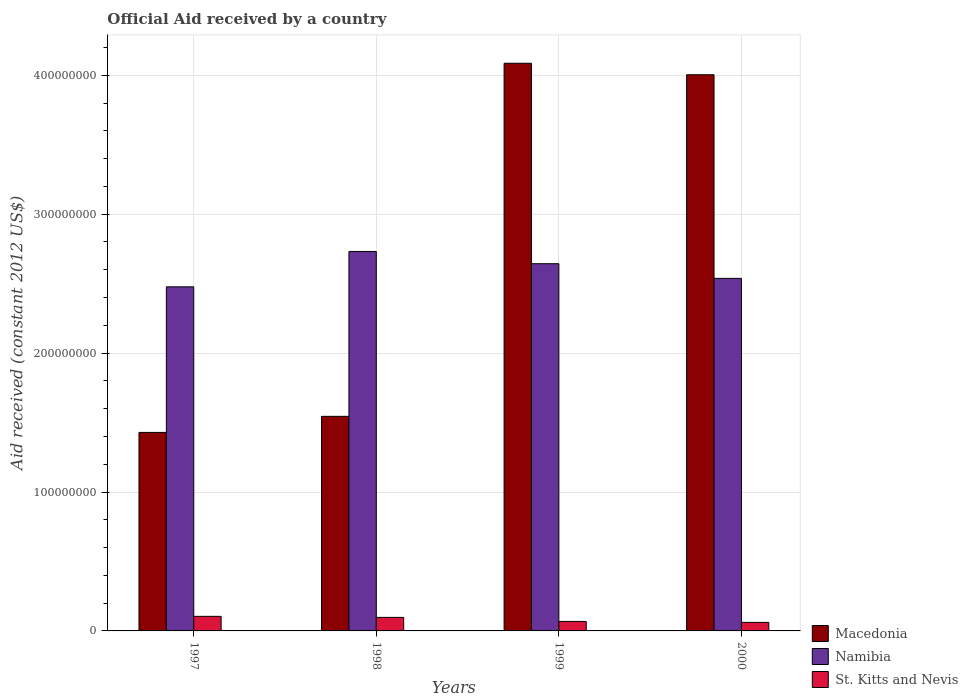How many different coloured bars are there?
Provide a succinct answer. 3. Are the number of bars per tick equal to the number of legend labels?
Your response must be concise. Yes. How many bars are there on the 1st tick from the left?
Provide a short and direct response. 3. How many bars are there on the 4th tick from the right?
Your answer should be compact. 3. What is the net official aid received in Macedonia in 1999?
Ensure brevity in your answer.  4.09e+08. Across all years, what is the maximum net official aid received in Namibia?
Give a very brief answer. 2.73e+08. Across all years, what is the minimum net official aid received in Namibia?
Offer a terse response. 2.48e+08. What is the total net official aid received in Namibia in the graph?
Offer a very short reply. 1.04e+09. What is the difference between the net official aid received in St. Kitts and Nevis in 1998 and that in 1999?
Keep it short and to the point. 2.92e+06. What is the difference between the net official aid received in Namibia in 1997 and the net official aid received in Macedonia in 1999?
Your response must be concise. -1.61e+08. What is the average net official aid received in St. Kitts and Nevis per year?
Your answer should be very brief. 8.30e+06. In the year 1999, what is the difference between the net official aid received in St. Kitts and Nevis and net official aid received in Macedonia?
Offer a very short reply. -4.02e+08. What is the ratio of the net official aid received in Namibia in 1997 to that in 1999?
Your answer should be compact. 0.94. Is the net official aid received in Namibia in 1997 less than that in 2000?
Provide a succinct answer. Yes. What is the difference between the highest and the second highest net official aid received in St. Kitts and Nevis?
Your response must be concise. 7.40e+05. What is the difference between the highest and the lowest net official aid received in Namibia?
Your response must be concise. 2.55e+07. In how many years, is the net official aid received in Namibia greater than the average net official aid received in Namibia taken over all years?
Ensure brevity in your answer.  2. What does the 2nd bar from the left in 1998 represents?
Your answer should be very brief. Namibia. What does the 3rd bar from the right in 1997 represents?
Keep it short and to the point. Macedonia. Is it the case that in every year, the sum of the net official aid received in Namibia and net official aid received in St. Kitts and Nevis is greater than the net official aid received in Macedonia?
Make the answer very short. No. Are all the bars in the graph horizontal?
Make the answer very short. No. How many legend labels are there?
Offer a very short reply. 3. How are the legend labels stacked?
Make the answer very short. Vertical. What is the title of the graph?
Your response must be concise. Official Aid received by a country. What is the label or title of the Y-axis?
Ensure brevity in your answer.  Aid received (constant 2012 US$). What is the Aid received (constant 2012 US$) of Macedonia in 1997?
Keep it short and to the point. 1.43e+08. What is the Aid received (constant 2012 US$) in Namibia in 1997?
Give a very brief answer. 2.48e+08. What is the Aid received (constant 2012 US$) in St. Kitts and Nevis in 1997?
Give a very brief answer. 1.05e+07. What is the Aid received (constant 2012 US$) in Macedonia in 1998?
Provide a succinct answer. 1.54e+08. What is the Aid received (constant 2012 US$) of Namibia in 1998?
Ensure brevity in your answer.  2.73e+08. What is the Aid received (constant 2012 US$) in St. Kitts and Nevis in 1998?
Keep it short and to the point. 9.75e+06. What is the Aid received (constant 2012 US$) of Macedonia in 1999?
Ensure brevity in your answer.  4.09e+08. What is the Aid received (constant 2012 US$) of Namibia in 1999?
Give a very brief answer. 2.64e+08. What is the Aid received (constant 2012 US$) of St. Kitts and Nevis in 1999?
Offer a very short reply. 6.83e+06. What is the Aid received (constant 2012 US$) of Macedonia in 2000?
Your response must be concise. 4.00e+08. What is the Aid received (constant 2012 US$) of Namibia in 2000?
Your response must be concise. 2.54e+08. What is the Aid received (constant 2012 US$) of St. Kitts and Nevis in 2000?
Provide a succinct answer. 6.15e+06. Across all years, what is the maximum Aid received (constant 2012 US$) in Macedonia?
Ensure brevity in your answer.  4.09e+08. Across all years, what is the maximum Aid received (constant 2012 US$) of Namibia?
Ensure brevity in your answer.  2.73e+08. Across all years, what is the maximum Aid received (constant 2012 US$) of St. Kitts and Nevis?
Keep it short and to the point. 1.05e+07. Across all years, what is the minimum Aid received (constant 2012 US$) of Macedonia?
Offer a very short reply. 1.43e+08. Across all years, what is the minimum Aid received (constant 2012 US$) in Namibia?
Your answer should be compact. 2.48e+08. Across all years, what is the minimum Aid received (constant 2012 US$) in St. Kitts and Nevis?
Provide a succinct answer. 6.15e+06. What is the total Aid received (constant 2012 US$) of Macedonia in the graph?
Provide a short and direct response. 1.11e+09. What is the total Aid received (constant 2012 US$) of Namibia in the graph?
Your answer should be compact. 1.04e+09. What is the total Aid received (constant 2012 US$) in St. Kitts and Nevis in the graph?
Your answer should be compact. 3.32e+07. What is the difference between the Aid received (constant 2012 US$) in Macedonia in 1997 and that in 1998?
Keep it short and to the point. -1.16e+07. What is the difference between the Aid received (constant 2012 US$) in Namibia in 1997 and that in 1998?
Ensure brevity in your answer.  -2.55e+07. What is the difference between the Aid received (constant 2012 US$) in St. Kitts and Nevis in 1997 and that in 1998?
Your answer should be very brief. 7.40e+05. What is the difference between the Aid received (constant 2012 US$) in Macedonia in 1997 and that in 1999?
Your answer should be compact. -2.66e+08. What is the difference between the Aid received (constant 2012 US$) of Namibia in 1997 and that in 1999?
Your answer should be very brief. -1.66e+07. What is the difference between the Aid received (constant 2012 US$) in St. Kitts and Nevis in 1997 and that in 1999?
Offer a very short reply. 3.66e+06. What is the difference between the Aid received (constant 2012 US$) in Macedonia in 1997 and that in 2000?
Your answer should be compact. -2.57e+08. What is the difference between the Aid received (constant 2012 US$) of Namibia in 1997 and that in 2000?
Give a very brief answer. -6.10e+06. What is the difference between the Aid received (constant 2012 US$) of St. Kitts and Nevis in 1997 and that in 2000?
Offer a very short reply. 4.34e+06. What is the difference between the Aid received (constant 2012 US$) in Macedonia in 1998 and that in 1999?
Your response must be concise. -2.54e+08. What is the difference between the Aid received (constant 2012 US$) of Namibia in 1998 and that in 1999?
Keep it short and to the point. 8.82e+06. What is the difference between the Aid received (constant 2012 US$) in St. Kitts and Nevis in 1998 and that in 1999?
Ensure brevity in your answer.  2.92e+06. What is the difference between the Aid received (constant 2012 US$) of Macedonia in 1998 and that in 2000?
Your answer should be very brief. -2.46e+08. What is the difference between the Aid received (constant 2012 US$) in Namibia in 1998 and that in 2000?
Your answer should be very brief. 1.94e+07. What is the difference between the Aid received (constant 2012 US$) in St. Kitts and Nevis in 1998 and that in 2000?
Offer a terse response. 3.60e+06. What is the difference between the Aid received (constant 2012 US$) of Macedonia in 1999 and that in 2000?
Your answer should be compact. 8.27e+06. What is the difference between the Aid received (constant 2012 US$) of Namibia in 1999 and that in 2000?
Provide a succinct answer. 1.06e+07. What is the difference between the Aid received (constant 2012 US$) in St. Kitts and Nevis in 1999 and that in 2000?
Your response must be concise. 6.80e+05. What is the difference between the Aid received (constant 2012 US$) of Macedonia in 1997 and the Aid received (constant 2012 US$) of Namibia in 1998?
Provide a succinct answer. -1.30e+08. What is the difference between the Aid received (constant 2012 US$) in Macedonia in 1997 and the Aid received (constant 2012 US$) in St. Kitts and Nevis in 1998?
Give a very brief answer. 1.33e+08. What is the difference between the Aid received (constant 2012 US$) of Namibia in 1997 and the Aid received (constant 2012 US$) of St. Kitts and Nevis in 1998?
Keep it short and to the point. 2.38e+08. What is the difference between the Aid received (constant 2012 US$) of Macedonia in 1997 and the Aid received (constant 2012 US$) of Namibia in 1999?
Your answer should be very brief. -1.21e+08. What is the difference between the Aid received (constant 2012 US$) of Macedonia in 1997 and the Aid received (constant 2012 US$) of St. Kitts and Nevis in 1999?
Offer a terse response. 1.36e+08. What is the difference between the Aid received (constant 2012 US$) in Namibia in 1997 and the Aid received (constant 2012 US$) in St. Kitts and Nevis in 1999?
Offer a terse response. 2.41e+08. What is the difference between the Aid received (constant 2012 US$) of Macedonia in 1997 and the Aid received (constant 2012 US$) of Namibia in 2000?
Offer a very short reply. -1.11e+08. What is the difference between the Aid received (constant 2012 US$) in Macedonia in 1997 and the Aid received (constant 2012 US$) in St. Kitts and Nevis in 2000?
Your answer should be compact. 1.37e+08. What is the difference between the Aid received (constant 2012 US$) of Namibia in 1997 and the Aid received (constant 2012 US$) of St. Kitts and Nevis in 2000?
Provide a succinct answer. 2.42e+08. What is the difference between the Aid received (constant 2012 US$) in Macedonia in 1998 and the Aid received (constant 2012 US$) in Namibia in 1999?
Offer a very short reply. -1.10e+08. What is the difference between the Aid received (constant 2012 US$) in Macedonia in 1998 and the Aid received (constant 2012 US$) in St. Kitts and Nevis in 1999?
Your answer should be compact. 1.48e+08. What is the difference between the Aid received (constant 2012 US$) in Namibia in 1998 and the Aid received (constant 2012 US$) in St. Kitts and Nevis in 1999?
Give a very brief answer. 2.66e+08. What is the difference between the Aid received (constant 2012 US$) in Macedonia in 1998 and the Aid received (constant 2012 US$) in Namibia in 2000?
Your response must be concise. -9.93e+07. What is the difference between the Aid received (constant 2012 US$) of Macedonia in 1998 and the Aid received (constant 2012 US$) of St. Kitts and Nevis in 2000?
Keep it short and to the point. 1.48e+08. What is the difference between the Aid received (constant 2012 US$) of Namibia in 1998 and the Aid received (constant 2012 US$) of St. Kitts and Nevis in 2000?
Make the answer very short. 2.67e+08. What is the difference between the Aid received (constant 2012 US$) in Macedonia in 1999 and the Aid received (constant 2012 US$) in Namibia in 2000?
Give a very brief answer. 1.55e+08. What is the difference between the Aid received (constant 2012 US$) in Macedonia in 1999 and the Aid received (constant 2012 US$) in St. Kitts and Nevis in 2000?
Offer a terse response. 4.03e+08. What is the difference between the Aid received (constant 2012 US$) in Namibia in 1999 and the Aid received (constant 2012 US$) in St. Kitts and Nevis in 2000?
Offer a terse response. 2.58e+08. What is the average Aid received (constant 2012 US$) of Macedonia per year?
Provide a succinct answer. 2.77e+08. What is the average Aid received (constant 2012 US$) of Namibia per year?
Offer a very short reply. 2.60e+08. What is the average Aid received (constant 2012 US$) of St. Kitts and Nevis per year?
Provide a short and direct response. 8.30e+06. In the year 1997, what is the difference between the Aid received (constant 2012 US$) of Macedonia and Aid received (constant 2012 US$) of Namibia?
Your answer should be compact. -1.05e+08. In the year 1997, what is the difference between the Aid received (constant 2012 US$) of Macedonia and Aid received (constant 2012 US$) of St. Kitts and Nevis?
Provide a succinct answer. 1.32e+08. In the year 1997, what is the difference between the Aid received (constant 2012 US$) in Namibia and Aid received (constant 2012 US$) in St. Kitts and Nevis?
Your response must be concise. 2.37e+08. In the year 1998, what is the difference between the Aid received (constant 2012 US$) of Macedonia and Aid received (constant 2012 US$) of Namibia?
Make the answer very short. -1.19e+08. In the year 1998, what is the difference between the Aid received (constant 2012 US$) of Macedonia and Aid received (constant 2012 US$) of St. Kitts and Nevis?
Ensure brevity in your answer.  1.45e+08. In the year 1998, what is the difference between the Aid received (constant 2012 US$) of Namibia and Aid received (constant 2012 US$) of St. Kitts and Nevis?
Give a very brief answer. 2.63e+08. In the year 1999, what is the difference between the Aid received (constant 2012 US$) of Macedonia and Aid received (constant 2012 US$) of Namibia?
Provide a short and direct response. 1.44e+08. In the year 1999, what is the difference between the Aid received (constant 2012 US$) in Macedonia and Aid received (constant 2012 US$) in St. Kitts and Nevis?
Offer a terse response. 4.02e+08. In the year 1999, what is the difference between the Aid received (constant 2012 US$) in Namibia and Aid received (constant 2012 US$) in St. Kitts and Nevis?
Provide a succinct answer. 2.58e+08. In the year 2000, what is the difference between the Aid received (constant 2012 US$) in Macedonia and Aid received (constant 2012 US$) in Namibia?
Your response must be concise. 1.47e+08. In the year 2000, what is the difference between the Aid received (constant 2012 US$) in Macedonia and Aid received (constant 2012 US$) in St. Kitts and Nevis?
Make the answer very short. 3.94e+08. In the year 2000, what is the difference between the Aid received (constant 2012 US$) of Namibia and Aid received (constant 2012 US$) of St. Kitts and Nevis?
Provide a succinct answer. 2.48e+08. What is the ratio of the Aid received (constant 2012 US$) in Macedonia in 1997 to that in 1998?
Your answer should be compact. 0.93. What is the ratio of the Aid received (constant 2012 US$) of Namibia in 1997 to that in 1998?
Provide a succinct answer. 0.91. What is the ratio of the Aid received (constant 2012 US$) of St. Kitts and Nevis in 1997 to that in 1998?
Your answer should be compact. 1.08. What is the ratio of the Aid received (constant 2012 US$) of Macedonia in 1997 to that in 1999?
Your answer should be very brief. 0.35. What is the ratio of the Aid received (constant 2012 US$) of Namibia in 1997 to that in 1999?
Your answer should be very brief. 0.94. What is the ratio of the Aid received (constant 2012 US$) in St. Kitts and Nevis in 1997 to that in 1999?
Ensure brevity in your answer.  1.54. What is the ratio of the Aid received (constant 2012 US$) of Macedonia in 1997 to that in 2000?
Give a very brief answer. 0.36. What is the ratio of the Aid received (constant 2012 US$) in Namibia in 1997 to that in 2000?
Give a very brief answer. 0.98. What is the ratio of the Aid received (constant 2012 US$) of St. Kitts and Nevis in 1997 to that in 2000?
Ensure brevity in your answer.  1.71. What is the ratio of the Aid received (constant 2012 US$) in Macedonia in 1998 to that in 1999?
Keep it short and to the point. 0.38. What is the ratio of the Aid received (constant 2012 US$) in Namibia in 1998 to that in 1999?
Your response must be concise. 1.03. What is the ratio of the Aid received (constant 2012 US$) in St. Kitts and Nevis in 1998 to that in 1999?
Your answer should be compact. 1.43. What is the ratio of the Aid received (constant 2012 US$) in Macedonia in 1998 to that in 2000?
Offer a very short reply. 0.39. What is the ratio of the Aid received (constant 2012 US$) of Namibia in 1998 to that in 2000?
Your answer should be very brief. 1.08. What is the ratio of the Aid received (constant 2012 US$) in St. Kitts and Nevis in 1998 to that in 2000?
Ensure brevity in your answer.  1.59. What is the ratio of the Aid received (constant 2012 US$) in Macedonia in 1999 to that in 2000?
Keep it short and to the point. 1.02. What is the ratio of the Aid received (constant 2012 US$) of Namibia in 1999 to that in 2000?
Give a very brief answer. 1.04. What is the ratio of the Aid received (constant 2012 US$) in St. Kitts and Nevis in 1999 to that in 2000?
Ensure brevity in your answer.  1.11. What is the difference between the highest and the second highest Aid received (constant 2012 US$) of Macedonia?
Ensure brevity in your answer.  8.27e+06. What is the difference between the highest and the second highest Aid received (constant 2012 US$) of Namibia?
Ensure brevity in your answer.  8.82e+06. What is the difference between the highest and the second highest Aid received (constant 2012 US$) in St. Kitts and Nevis?
Your response must be concise. 7.40e+05. What is the difference between the highest and the lowest Aid received (constant 2012 US$) of Macedonia?
Give a very brief answer. 2.66e+08. What is the difference between the highest and the lowest Aid received (constant 2012 US$) in Namibia?
Make the answer very short. 2.55e+07. What is the difference between the highest and the lowest Aid received (constant 2012 US$) in St. Kitts and Nevis?
Offer a very short reply. 4.34e+06. 